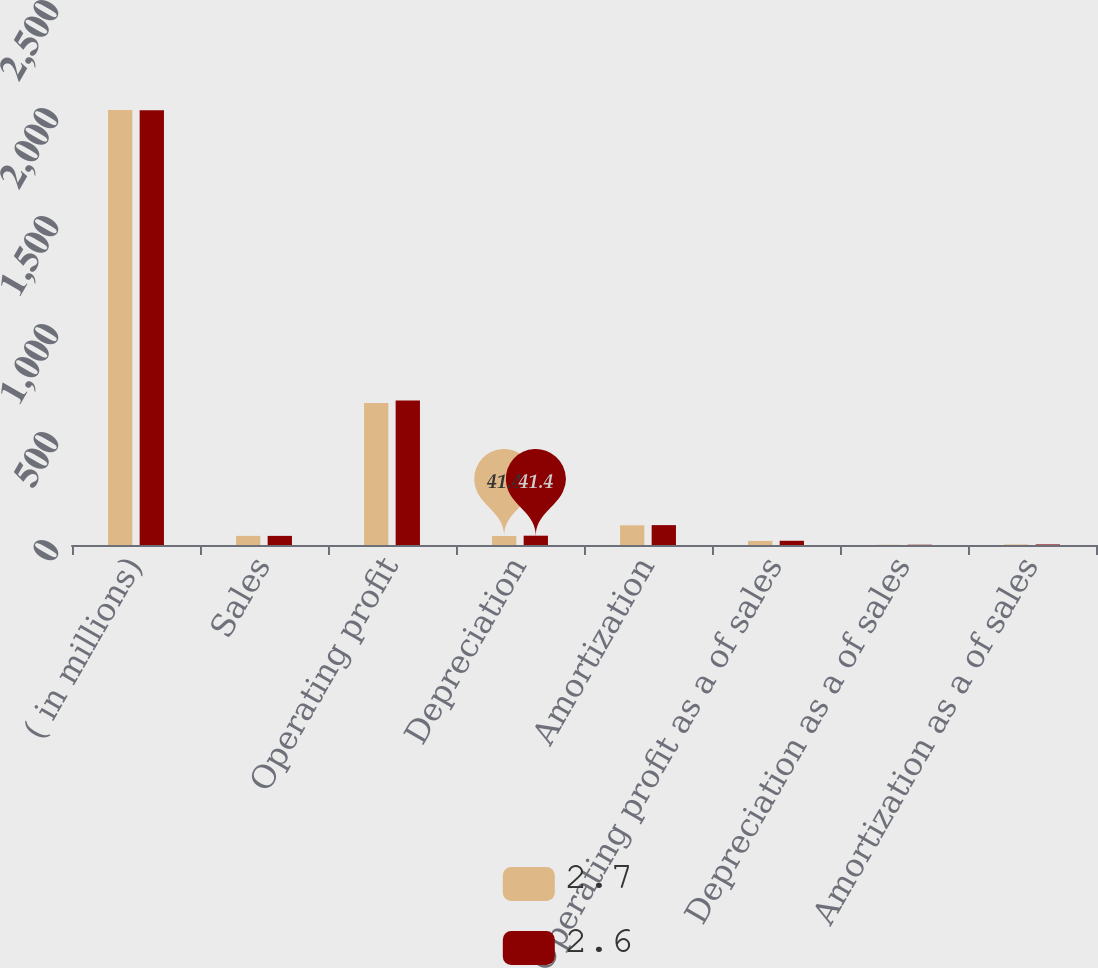Convert chart to OTSL. <chart><loc_0><loc_0><loc_500><loc_500><stacked_bar_chart><ecel><fcel>( in millions)<fcel>Sales<fcel>Operating profit<fcel>Depreciation<fcel>Amortization<fcel>Operating profit as a of sales<fcel>Depreciation as a of sales<fcel>Amortization as a of sales<nl><fcel>2.7<fcel>2014<fcel>42.25<fcel>657.9<fcel>41.4<fcel>91.1<fcel>19<fcel>1.2<fcel>2.6<nl><fcel>2.6<fcel>2013<fcel>42.25<fcel>669.5<fcel>43.1<fcel>92<fcel>19.6<fcel>1.3<fcel>2.7<nl></chart> 